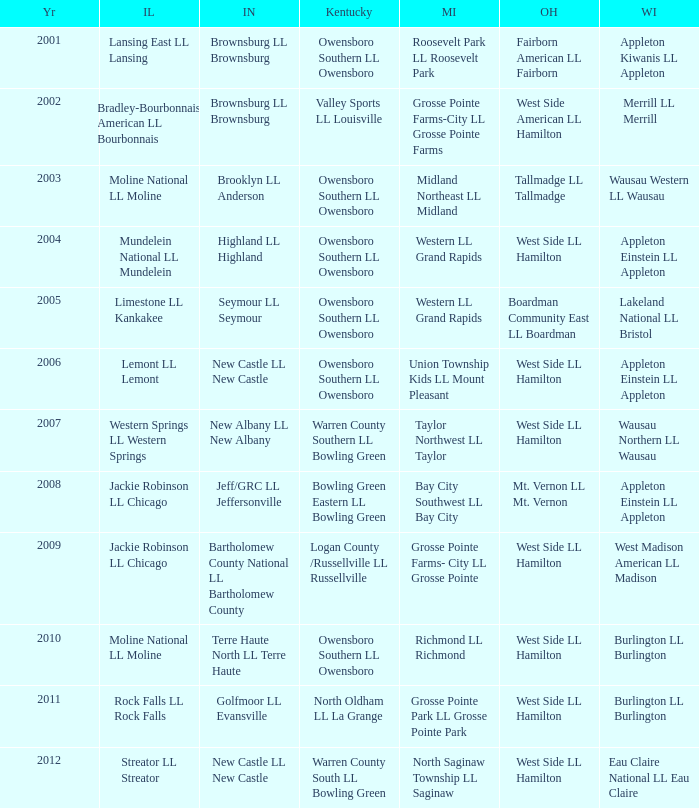What was the little league team from Ohio when the little league team from Kentucky was Warren County South LL Bowling Green? West Side LL Hamilton. 